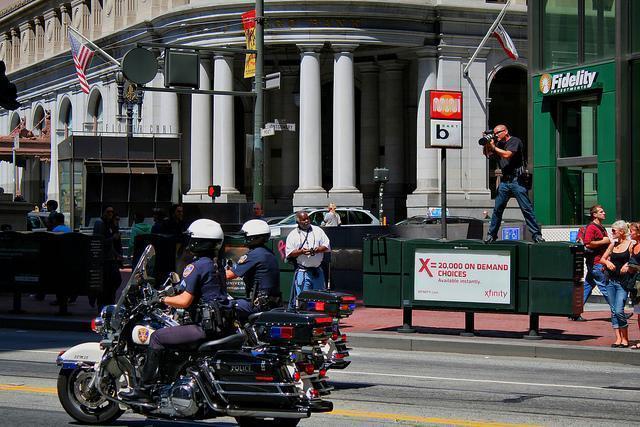What is the man standing on the green sign doing?
Make your selection from the four choices given to correctly answer the question.
Options: Protesting, exercising, photographing, dancing. Photographing. 